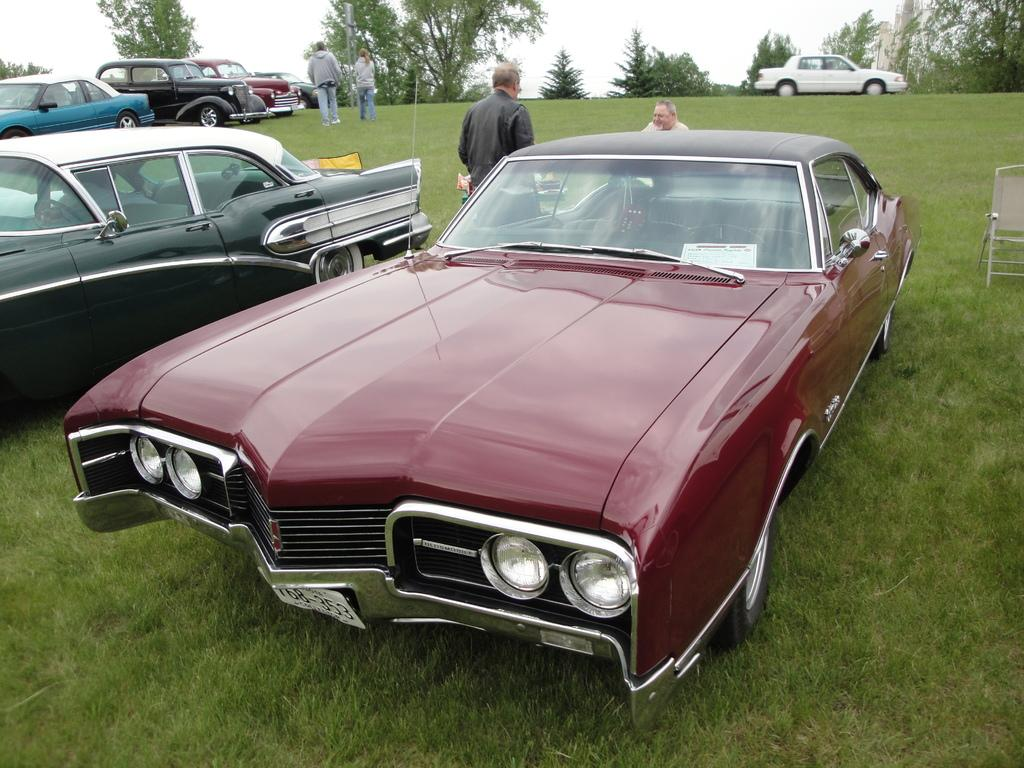What type of vehicles can be seen in the image? There are cars on a greenery ground in the image. How many people are present in the image? There are four persons in the image. What can be seen in the background of the image? Trees are present in the background of the image. What type of jam is being spread on the trees in the image? There is no jam present in the image, and the trees are not being used for spreading jam. 